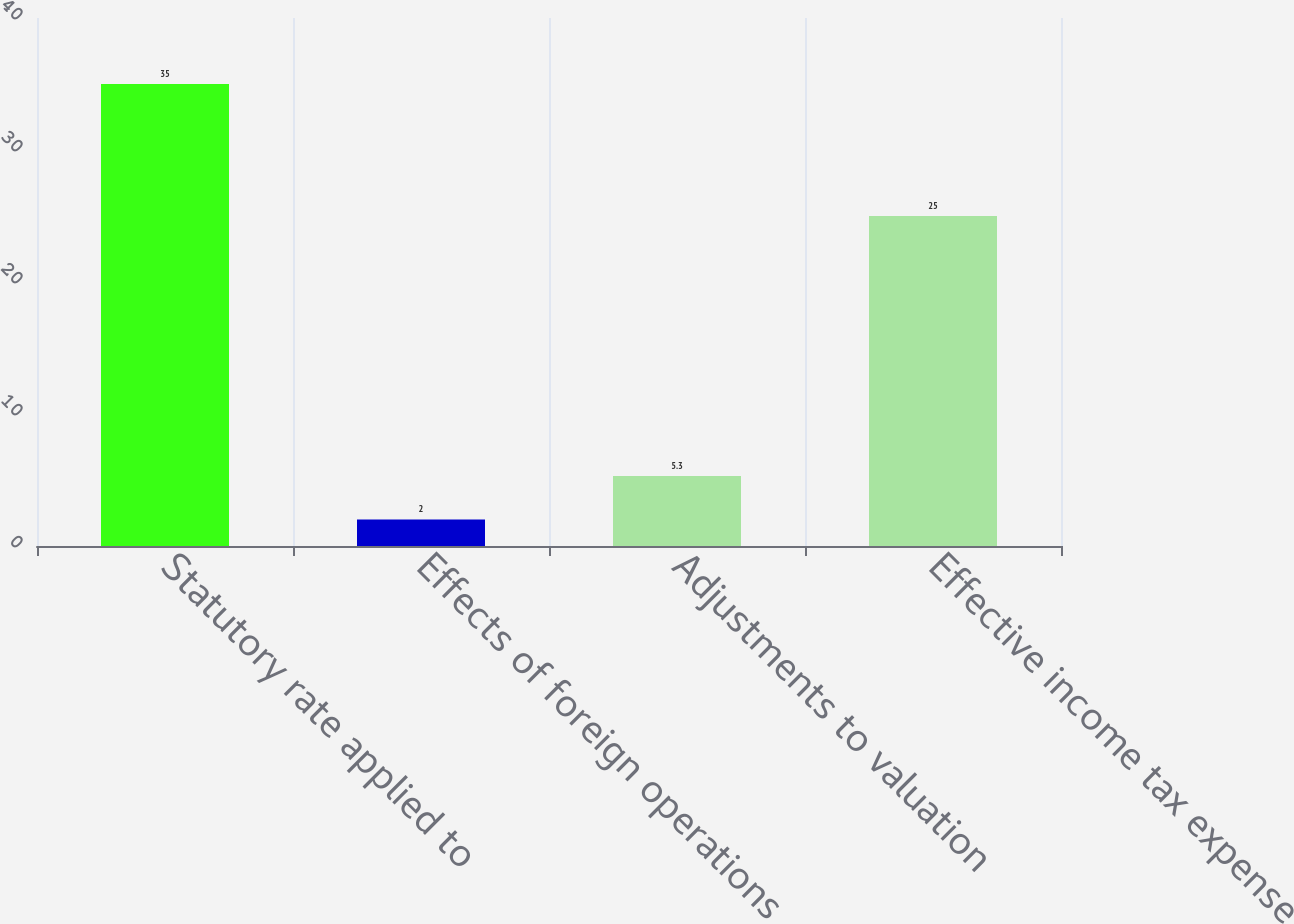Convert chart. <chart><loc_0><loc_0><loc_500><loc_500><bar_chart><fcel>Statutory rate applied to<fcel>Effects of foreign operations<fcel>Adjustments to valuation<fcel>Effective income tax expense<nl><fcel>35<fcel>2<fcel>5.3<fcel>25<nl></chart> 